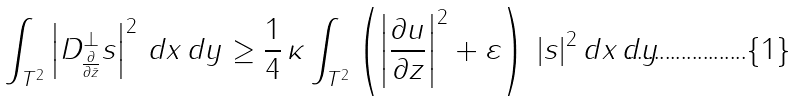Convert formula to latex. <formula><loc_0><loc_0><loc_500><loc_500>\int _ { T ^ { 2 } } \left | D _ { \frac { \partial } { \partial \bar { z } } } ^ { \perp } s \right | ^ { 2 } \, d x \, d y \geq \frac { 1 } { 4 } \, \kappa \int _ { T ^ { 2 } } \left ( \left | \frac { \partial u } { \partial z } \right | ^ { 2 } + \varepsilon \right ) \, | s | ^ { 2 } \, d x \, d y</formula> 